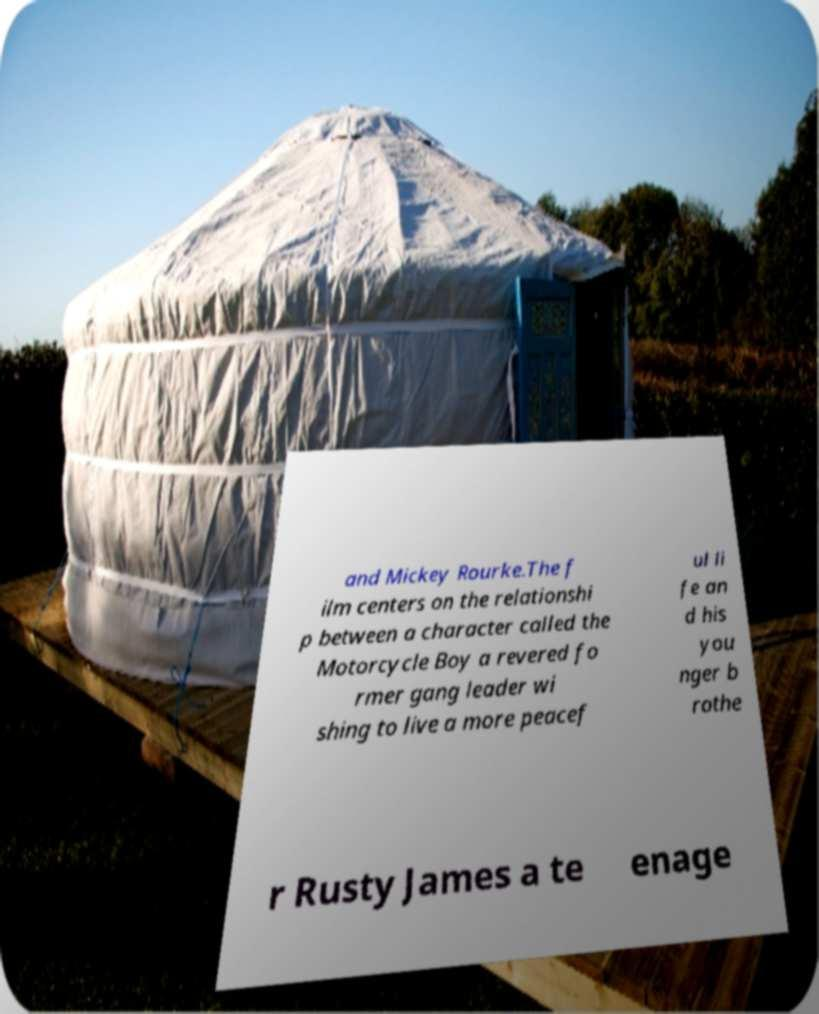I need the written content from this picture converted into text. Can you do that? and Mickey Rourke.The f ilm centers on the relationshi p between a character called the Motorcycle Boy a revered fo rmer gang leader wi shing to live a more peacef ul li fe an d his you nger b rothe r Rusty James a te enage 